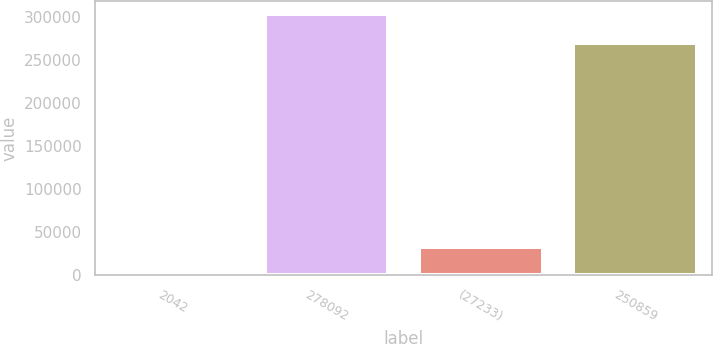Convert chart to OTSL. <chart><loc_0><loc_0><loc_500><loc_500><bar_chart><fcel>2042<fcel>278092<fcel>(27233)<fcel>250859<nl><fcel>18.32<fcel>303192<fcel>33096<fcel>270096<nl></chart> 